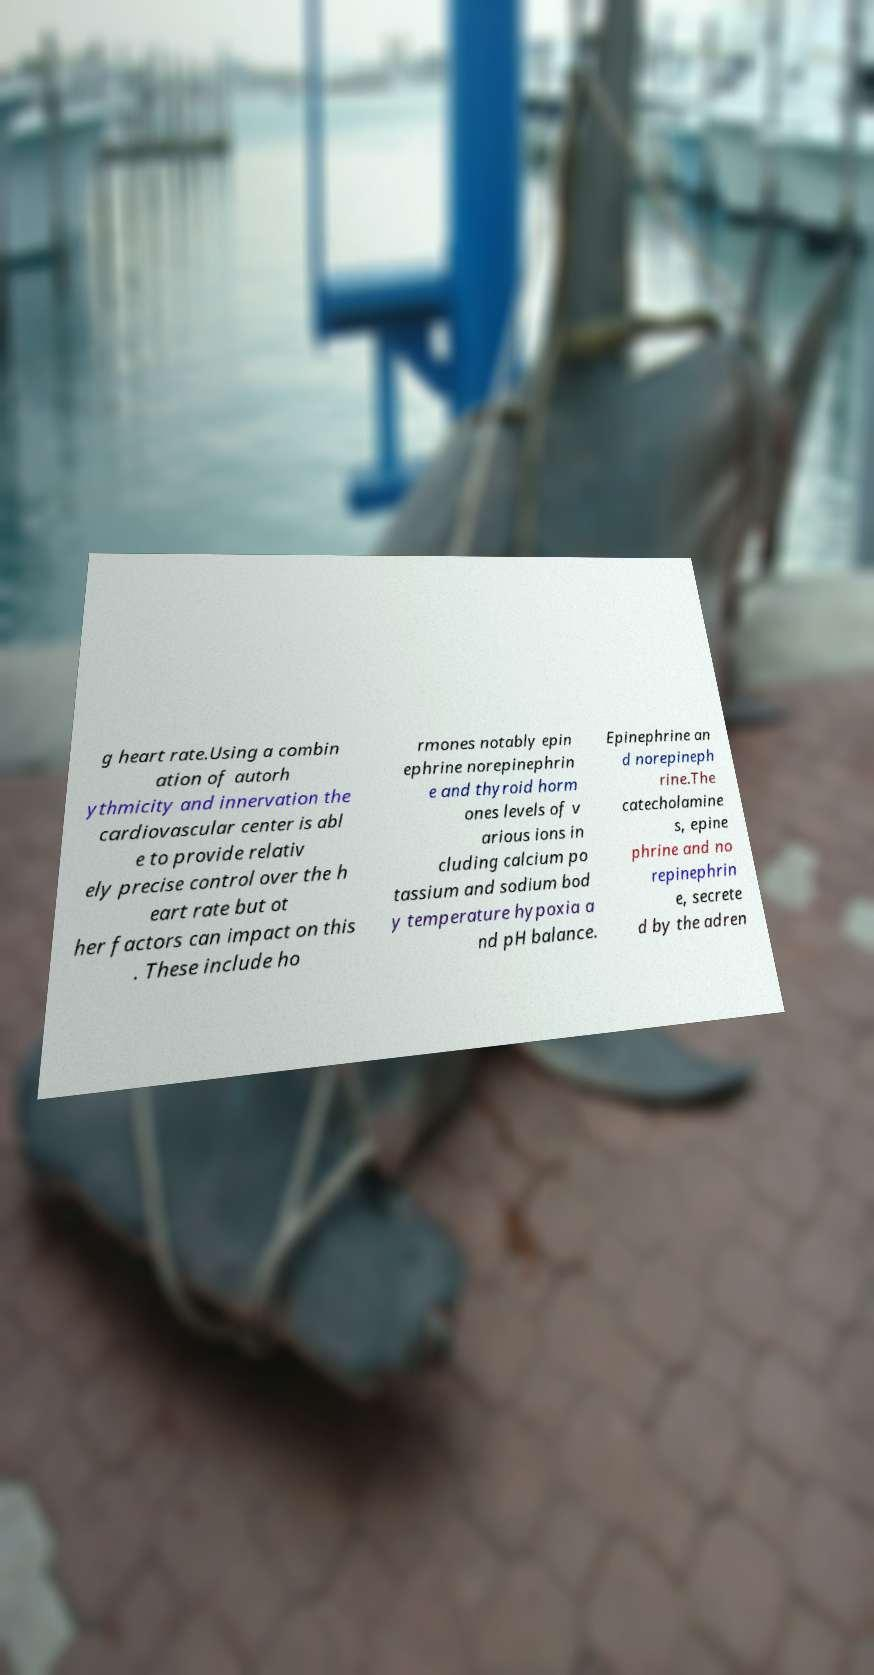There's text embedded in this image that I need extracted. Can you transcribe it verbatim? g heart rate.Using a combin ation of autorh ythmicity and innervation the cardiovascular center is abl e to provide relativ ely precise control over the h eart rate but ot her factors can impact on this . These include ho rmones notably epin ephrine norepinephrin e and thyroid horm ones levels of v arious ions in cluding calcium po tassium and sodium bod y temperature hypoxia a nd pH balance. Epinephrine an d norepineph rine.The catecholamine s, epine phrine and no repinephrin e, secrete d by the adren 